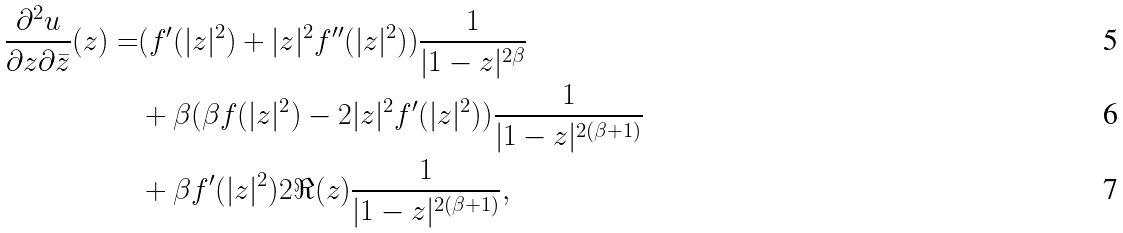Convert formula to latex. <formula><loc_0><loc_0><loc_500><loc_500>\frac { \partial ^ { 2 } u } { \partial z \partial \bar { z } } ( z ) = & ( f ^ { \prime } ( | z | ^ { 2 } ) + | z | ^ { 2 } f ^ { \prime \prime } ( | z | ^ { 2 } ) ) \frac { 1 } { | 1 - z | ^ { 2 \beta } } \\ & + \beta ( \beta f ( | z | ^ { 2 } ) - 2 | z | ^ { 2 } f ^ { \prime } ( | z | ^ { 2 } ) ) \frac { 1 } { | 1 - z | ^ { 2 ( \beta + 1 ) } } \\ & + \beta f ^ { \prime } ( | z | ^ { 2 } ) 2 \Re ( z ) \frac { 1 } { | 1 - z | ^ { 2 ( \beta + 1 ) } } ,</formula> 